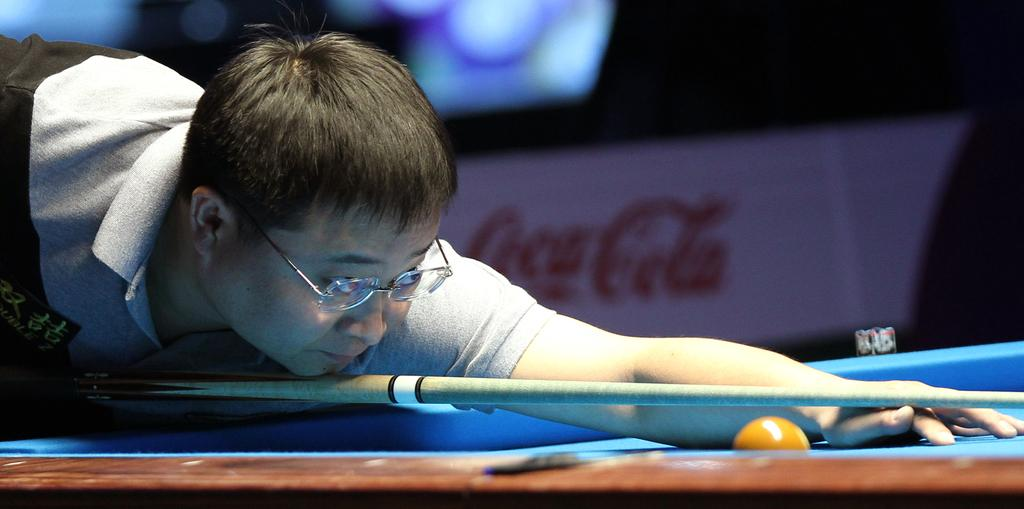Who is the main subject in the image? There is a man in the image. What is the man doing in the image? The man is playing a snooker game. Can you describe the background of the image? The background of the image is blurry. What is the man's net worth in the image? There is no information about the man's net worth in the image. How does the man's wealth affect his ability to play snooker in the image? There is no information about the man's wealth in the image, so we cannot determine how it affects his ability to play snooker. 